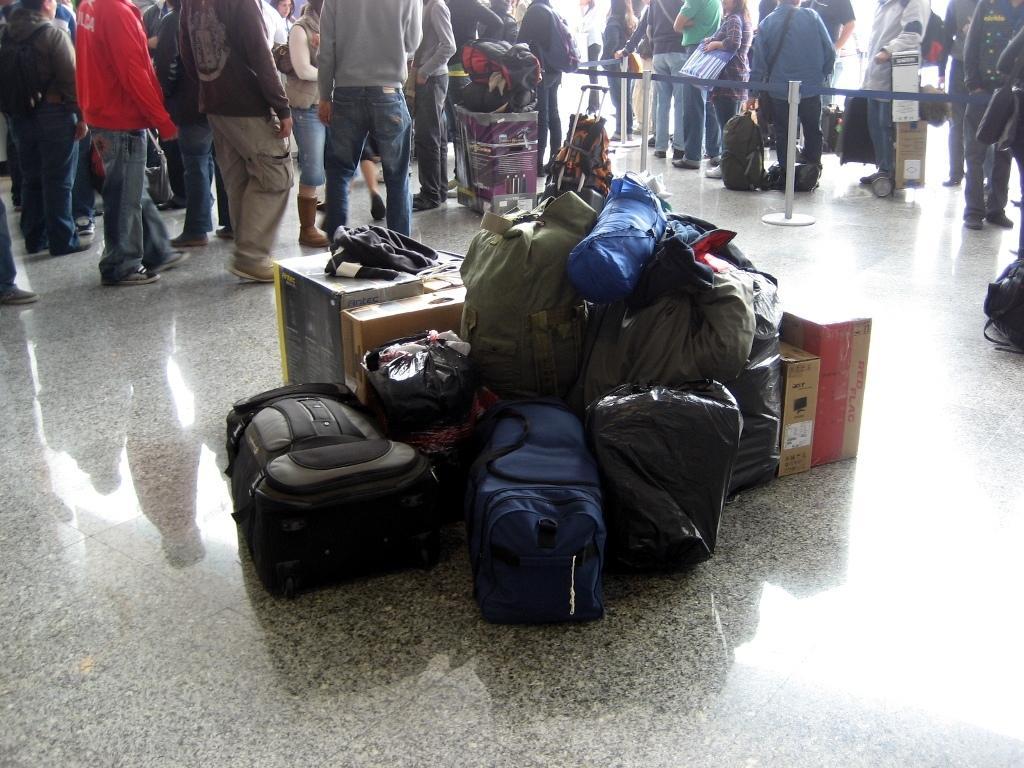Describe this image in one or two sentences. In this image all the luggage of the passenger is kept on the floor. At the background there are people standing in the queue with their luggages in the hand. There are bags,boxes,covers,trolleys kept on the floor. To the left side their are people who are walking with their luggage in their hand. 